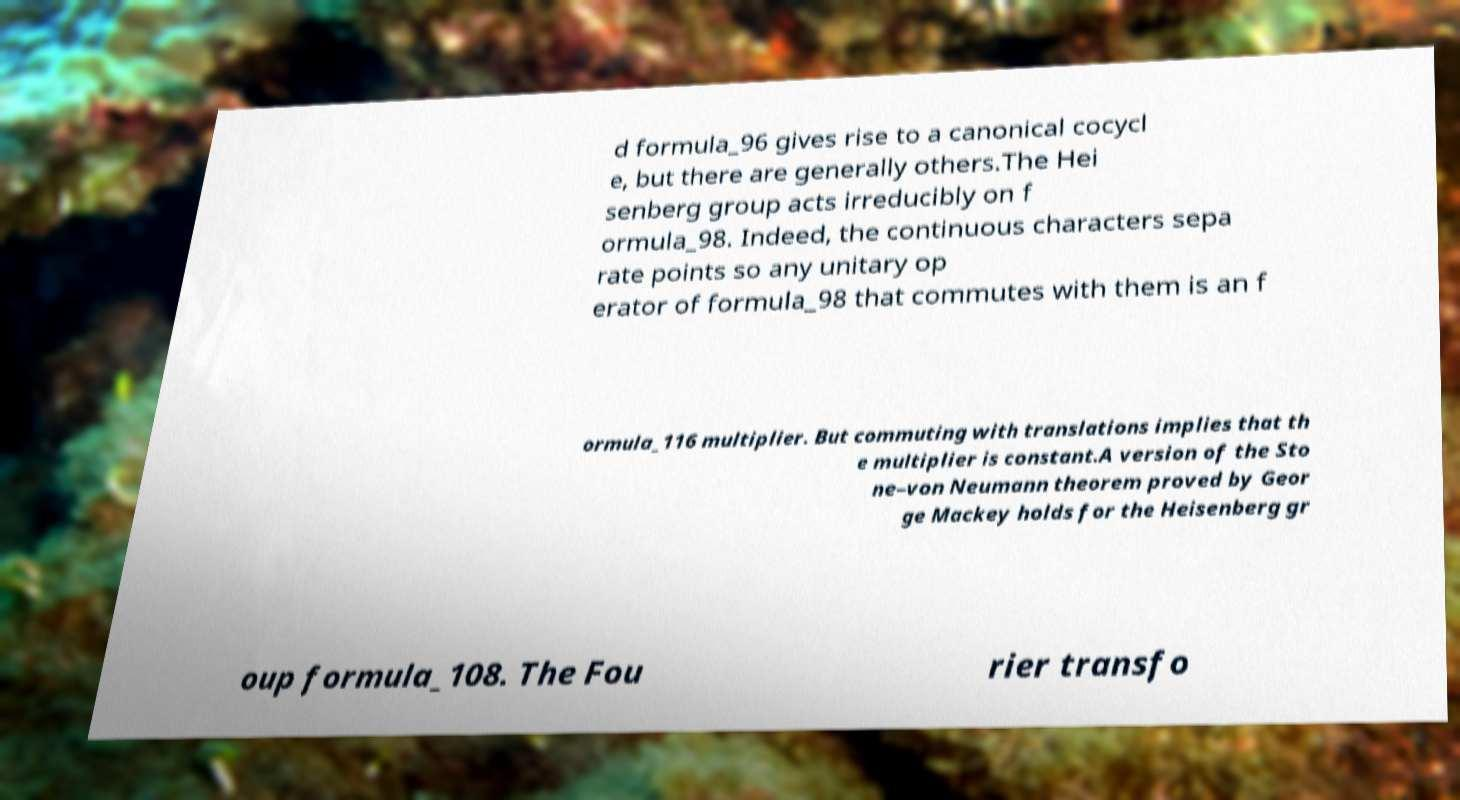There's text embedded in this image that I need extracted. Can you transcribe it verbatim? d formula_96 gives rise to a canonical cocycl e, but there are generally others.The Hei senberg group acts irreducibly on f ormula_98. Indeed, the continuous characters sepa rate points so any unitary op erator of formula_98 that commutes with them is an f ormula_116 multiplier. But commuting with translations implies that th e multiplier is constant.A version of the Sto ne–von Neumann theorem proved by Geor ge Mackey holds for the Heisenberg gr oup formula_108. The Fou rier transfo 